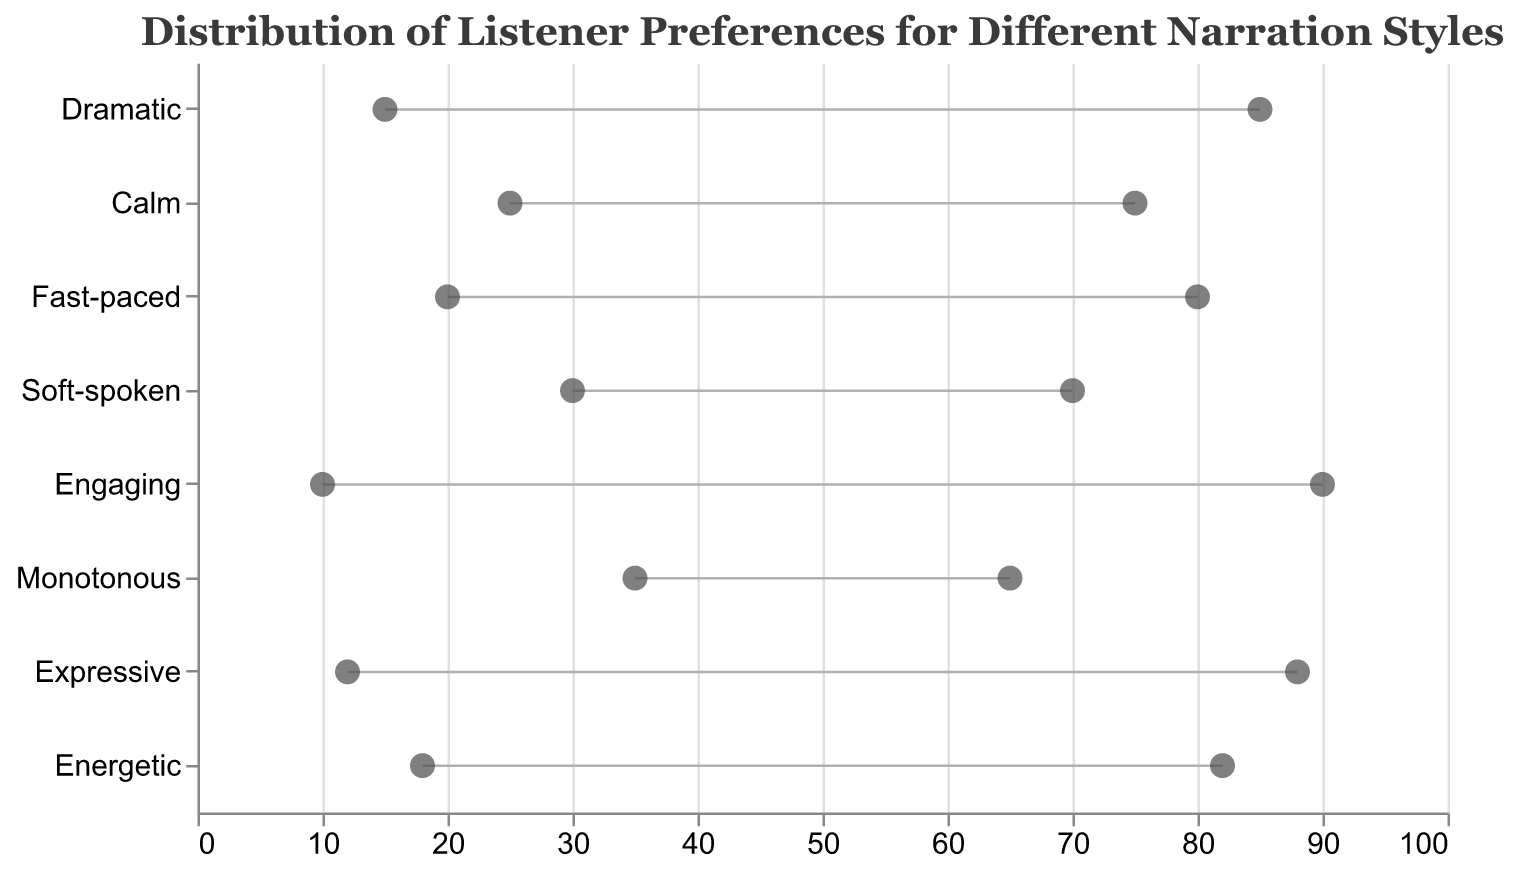Which narration style has the highest high preference value? To determine which narration style has the highest high preference, look for the narration style with the largest value in the high preference range. The "Engaging" narration style has a high preference value of 90, which is the highest in the dataset.
Answer: Engaging Which narration style has the lowest low preference value? To find the narration style with the lowest low preference value, look for the smallest value in the low preference range. The "Engaging" narration style has the lowest low preference value of 10.
Answer: Engaging What is the range of preference for the "Dramatic" narration style? To find the range of preference for "Dramatic," subtract the low preference value from the high preference value: 85 - 15 = 70.
Answer: 70 Which narration styles have a high preference value higher than 80? To identify narration styles with high preference values greater than 80, check each narration style's high preference value. "Dramatic" (85), "Fast-paced" (80), "Expressive" (88), and "Energetic" (82) all exceed 80.
Answer: Dramatic, Expressive, Energetic What is the average low preference value across all narration styles? Calculate the average low preference value by summing all the low preference values and dividing by the number of narration styles: (15 + 25 + 20 + 30 + 10 + 35 + 12 + 18)/8 = 20.625.
Answer: 20.625 Which narration style has the smallest range of preference? To find the narration style with the smallest range, subtract the low preference value from the high preference value for each style and identify the minimum. "Monotonous" has a preference range of 65 - 35 = 30, which is the smallest.
Answer: Monotonous How does the preference for "Soft-spoken" compare to "Monotonous"? Compare both the low and high preference values for each style. "Soft-spoken" has a preference range of 30-70, while "Monotonous" has 35-65. "Soft-spoken" has a higher high preference and a lower low preference than "Monotonous."
Answer: Soft-spoken has a higher high preference and a lower low preference Which narration style has the largest gap between low and high preference values? Identify the narrations style with the highest difference between its low and high preference values. "Engaging" has a gap of 90 - 10 = 80, the largest in the dataset.
Answer: Engaging 